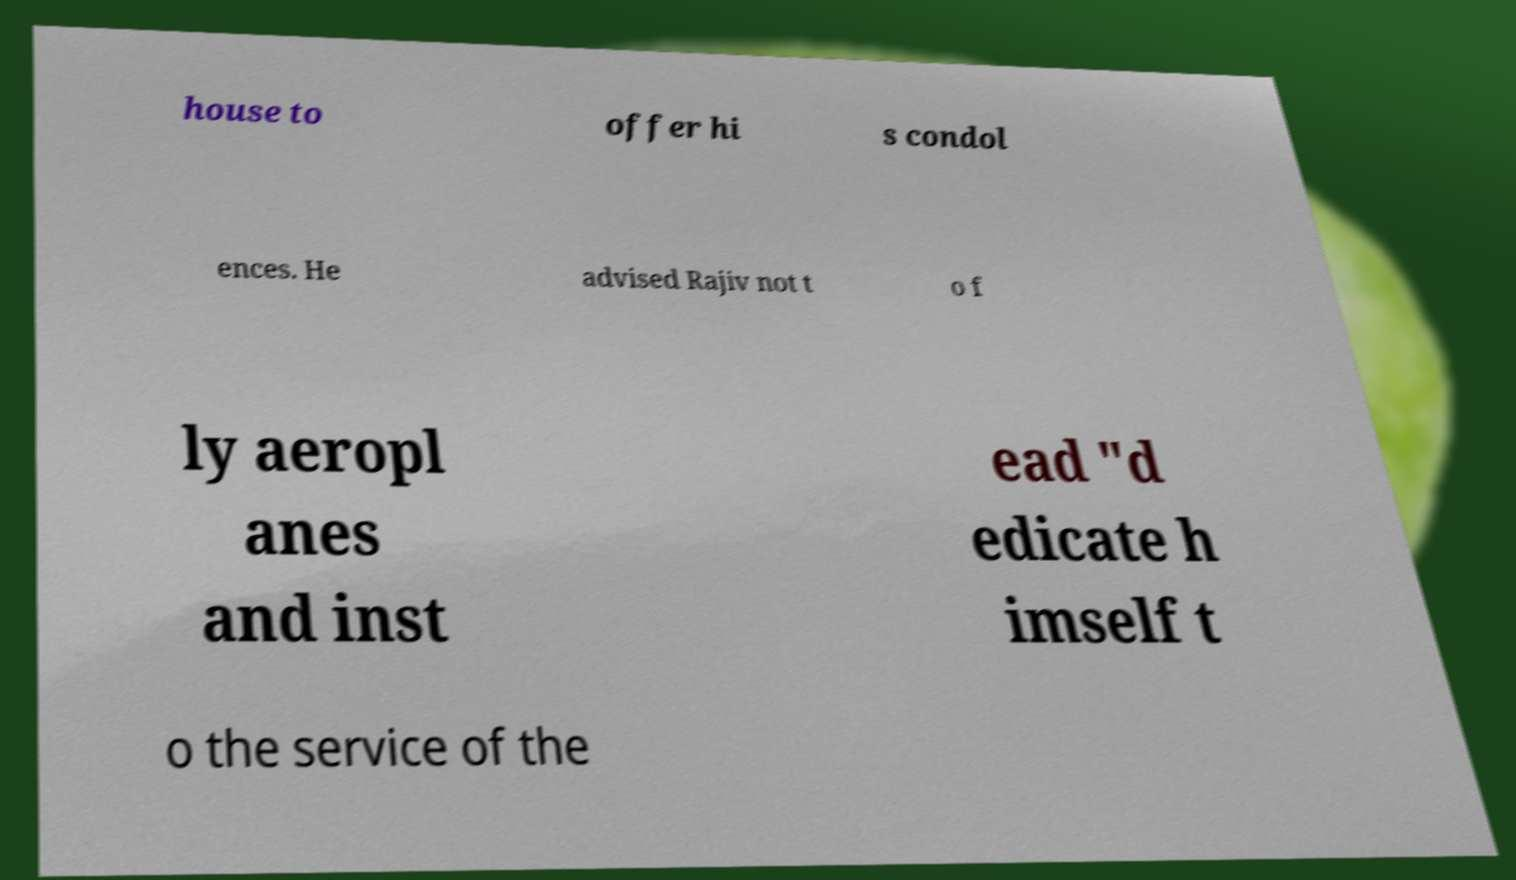Could you extract and type out the text from this image? house to offer hi s condol ences. He advised Rajiv not t o f ly aeropl anes and inst ead "d edicate h imself t o the service of the 